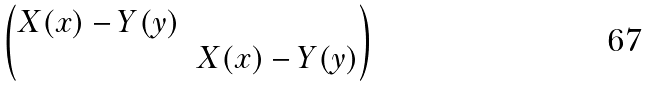Convert formula to latex. <formula><loc_0><loc_0><loc_500><loc_500>\begin{pmatrix} X ( x ) - Y ( y ) & \\ & X ( x ) - Y ( y ) \end{pmatrix}</formula> 